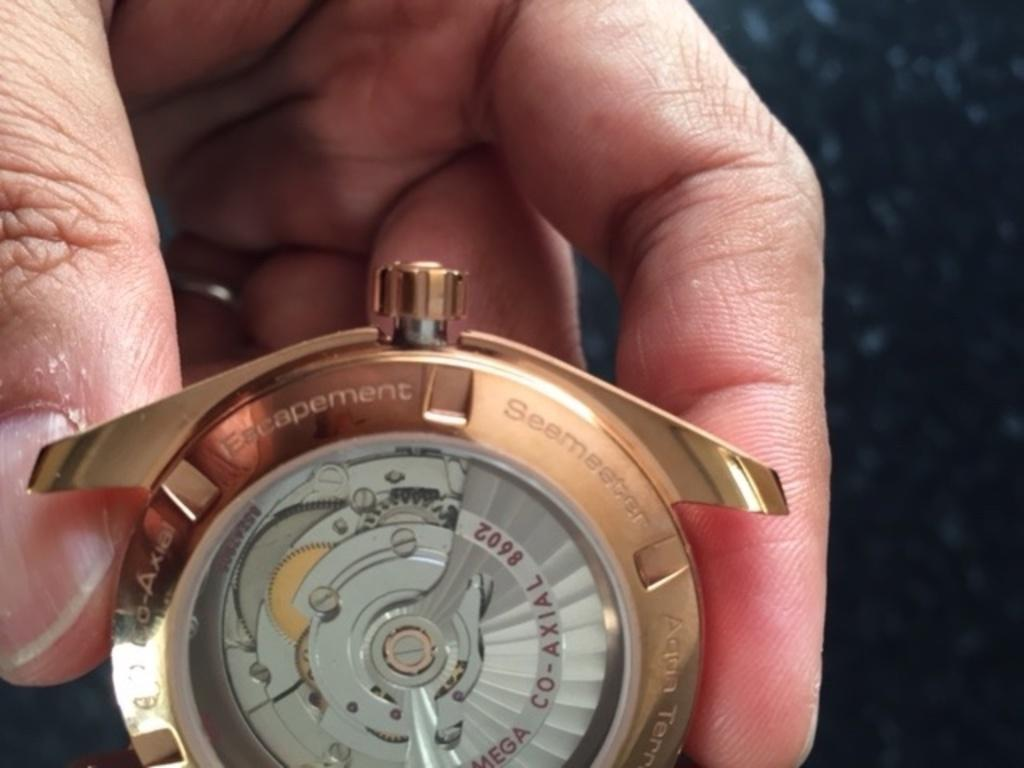<image>
Create a compact narrative representing the image presented. Someone is holding a watch with the number 8602 on one of the parts inside. 